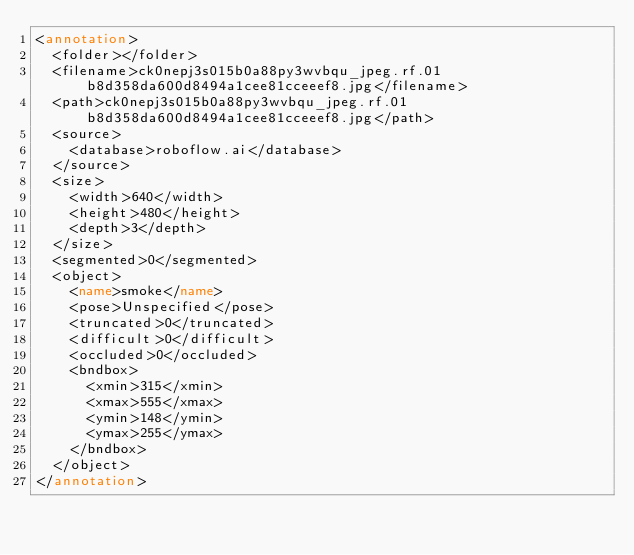<code> <loc_0><loc_0><loc_500><loc_500><_XML_><annotation>
	<folder></folder>
	<filename>ck0nepj3s015b0a88py3wvbqu_jpeg.rf.01b8d358da600d8494a1cee81cceeef8.jpg</filename>
	<path>ck0nepj3s015b0a88py3wvbqu_jpeg.rf.01b8d358da600d8494a1cee81cceeef8.jpg</path>
	<source>
		<database>roboflow.ai</database>
	</source>
	<size>
		<width>640</width>
		<height>480</height>
		<depth>3</depth>
	</size>
	<segmented>0</segmented>
	<object>
		<name>smoke</name>
		<pose>Unspecified</pose>
		<truncated>0</truncated>
		<difficult>0</difficult>
		<occluded>0</occluded>
		<bndbox>
			<xmin>315</xmin>
			<xmax>555</xmax>
			<ymin>148</ymin>
			<ymax>255</ymax>
		</bndbox>
	</object>
</annotation>
</code> 